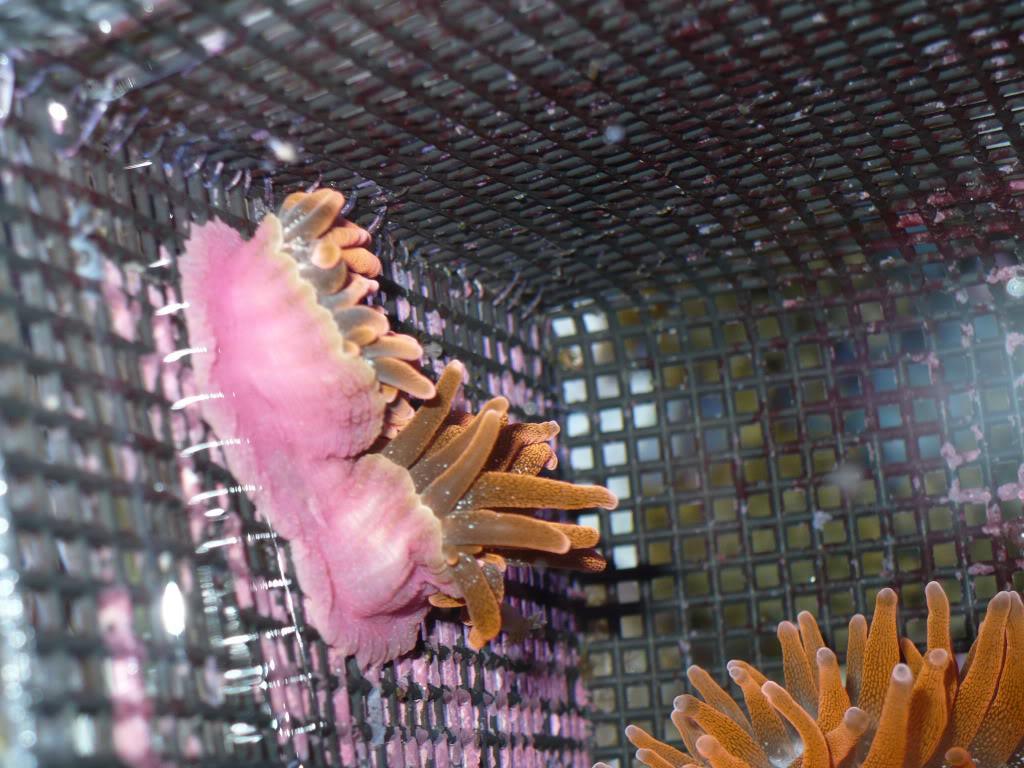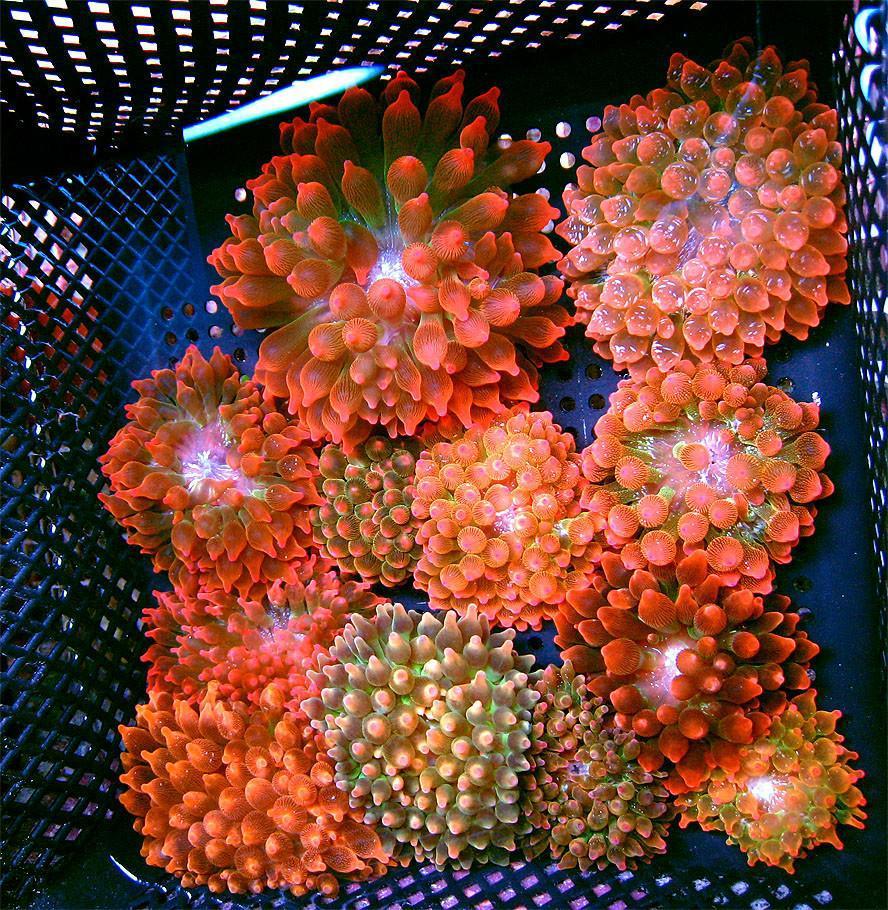The first image is the image on the left, the second image is the image on the right. Given the left and right images, does the statement "Atleast one image shows anemone growing on a grid surface, and at least one image features orange-tentacled anemone with pink stalks." hold true? Answer yes or no. Yes. The first image is the image on the left, the second image is the image on the right. Given the left and right images, does the statement "In the image on the right, sea anemones rest in a container with holes in it." hold true? Answer yes or no. Yes. 